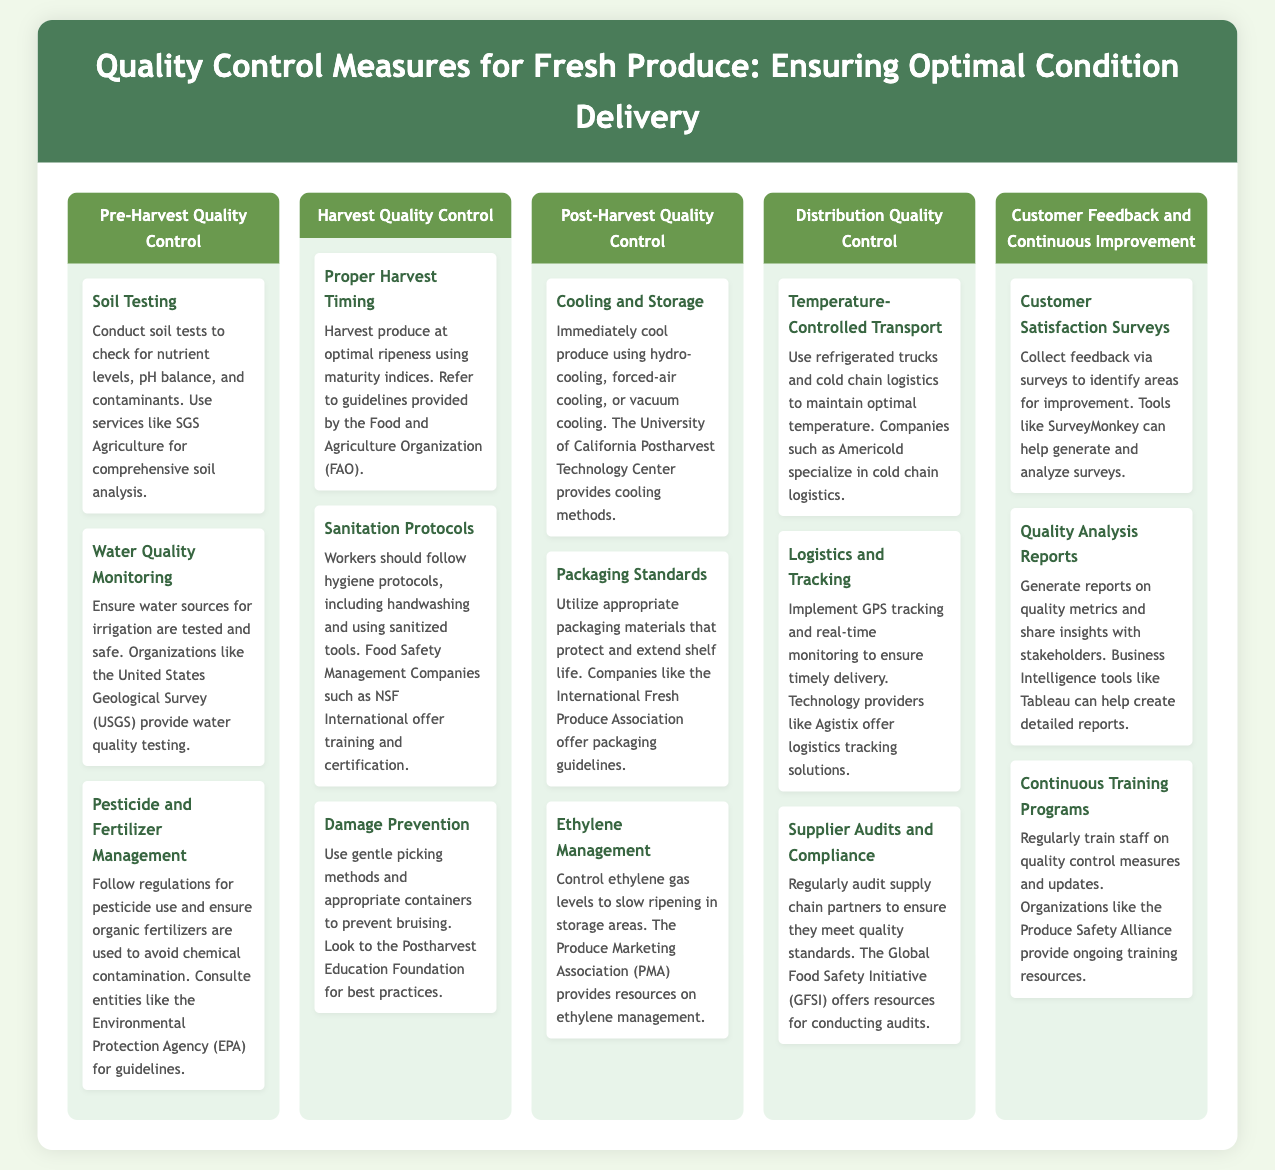What are the three main areas of quality control? The document lists five main areas: Pre-Harvest Quality Control, Harvest Quality Control, Post-Harvest Quality Control, Distribution Quality Control, and Customer Feedback and Continuous Improvement.
Answer: Pre-Harvest, Harvest, Post-Harvest, Distribution, Customer Feedback What is a method to ensure proper water quality? The document suggests testing water sources for irrigation through organizations like the United States Geological Survey (USGS).
Answer: Water quality monitoring What is the organization that provides training for sanitation protocols? The document mentions NSF International as a Food Safety Management Company that offers training and certification on sanitation protocols.
Answer: NSF International Which method is recommended for managing ethylene levels? The document states to control ethylene gas levels to slow ripening in storage areas, with resources available from the Produce Marketing Association (PMA).
Answer: Ethylene management What type of transport should be used to maintain temperature? The document advises using refrigerated trucks and cold chain logistics for maintaining optimal temperature during transport.
Answer: Temperature-Controlled Transport What is one tool mentioned for generating customer satisfaction surveys? According to the document, tools like SurveyMonkey can help generate and analyze customer satisfaction surveys.
Answer: SurveyMonkey What should be audited to ensure quality standards? The document indicates that supply chain partners should be audited regularly to ensure they meet quality standards.
Answer: Supplier audits and compliance Which organization provides ongoing training resources for quality control measures? The document lists the Produce Safety Alliance as an organization that provides ongoing training resources for quality control measures.
Answer: Produce Safety Alliance What cooling method is mentioned for post-harvest quality control? The document describes hydro-cooling, forced-air cooling, or vacuum cooling as immediate cooling methods for produce.
Answer: Cooling and Storage 